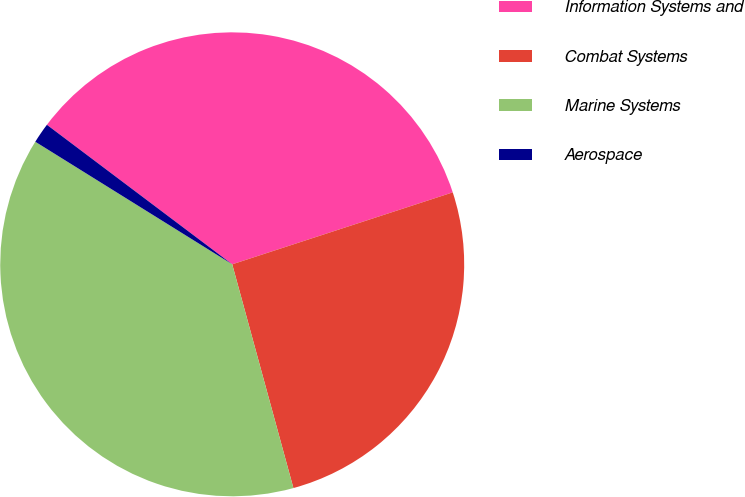<chart> <loc_0><loc_0><loc_500><loc_500><pie_chart><fcel>Information Systems and<fcel>Combat Systems<fcel>Marine Systems<fcel>Aerospace<nl><fcel>34.71%<fcel>25.77%<fcel>38.11%<fcel>1.41%<nl></chart> 